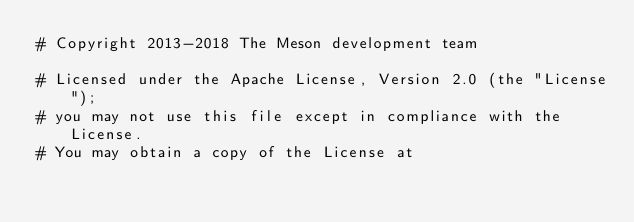Convert code to text. <code><loc_0><loc_0><loc_500><loc_500><_Python_># Copyright 2013-2018 The Meson development team

# Licensed under the Apache License, Version 2.0 (the "License");
# you may not use this file except in compliance with the License.
# You may obtain a copy of the License at
</code> 